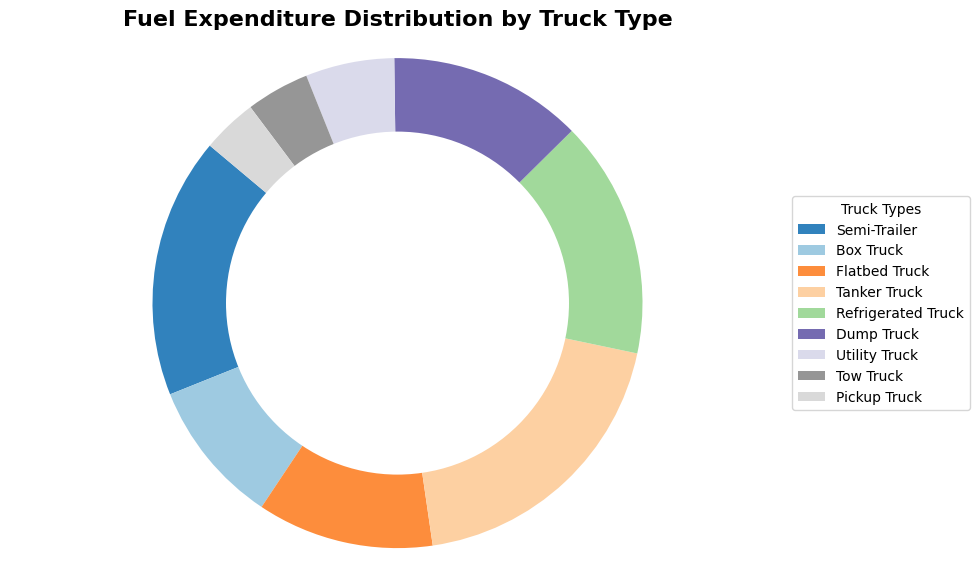What's the truck type with the highest fuel expenditure? To answer this question, look at the pie slices and their corresponding labels. Identify the slice that occupies the largest portion of the pie and find its corresponding truck type.
Answer: Tanker Truck Which truck type has the lowest fuel expenditure percentage? To answer this, find the smallest pie slice and check its associated label. This will indicate the truck type with the lowest fuel expenditure.
Answer: Pickup Truck How much more fuel expenditure does the Semi-Trailer have compared to the Box Truck? Look at the fuel expenditure values for both Semi-Trailer ($255,000) and Box Truck ($142,000). Subtract the Box Truck's value from the Semi-Trailer's value: $255,000 - $142,000 = $113,000.
Answer: $113,000 Which truck types together account for more than 50% of the total fuel expenditure? First, identify the truck types with the largest pie slices. Then, add their fuel expenditures and check if they exceed 50% of the total. The largest portions include Tanker Truck ($288,000) and Semi-Trailer ($255,000). Add these to get $288,000 + $255,000 = $543,000. Check the percentage: ($543,000 / $1,292,000) * 100 = 42.0% from this and adding the next largest slice, Refrigerator Truck ($233,000). Finally, $543,000 + $233,000 = $776,000 which is 60.0% of the total fuel expenses.
Answer: Tanker Truck, Semi-Trailer, Refrigerated Truck What is the average fuel expenditure of the Semi-Trailer, Flatbed Truck, and Tow Truck combined? Add the fuel expenditures for the three truck types and divide by 3. Semi-Trailer: $255,000, Flatbed Truck: $173,000, Tow Truck: $62,000. Sum these: $255,000 + $173,000 + $62,000 = $490,000. Average: $490,000 / 3 = $163,333.33.
Answer: $163,333.33 Is the fuel expenditure of the Utility Truck more or less than that of the Dump Truck? Compare the values associated with the Utility Truck ($87,000) and the Dump Truck ($190,000). Since $87,000 is less than $190,000, the Utility Truck has less fuel expenditure.
Answer: Less What is the total fuel expenditure for Box Trucks, Flatbed Trucks, and Dump Trucks combined? Add the fuel expenditures for these truck types: Box Truck ($142,000), Flatbed Truck ($173,000), and Dump Truck ($190,000). Sum these values: $142,000 + $173,000 + $190,000 = $505,000.
Answer: $505,000 